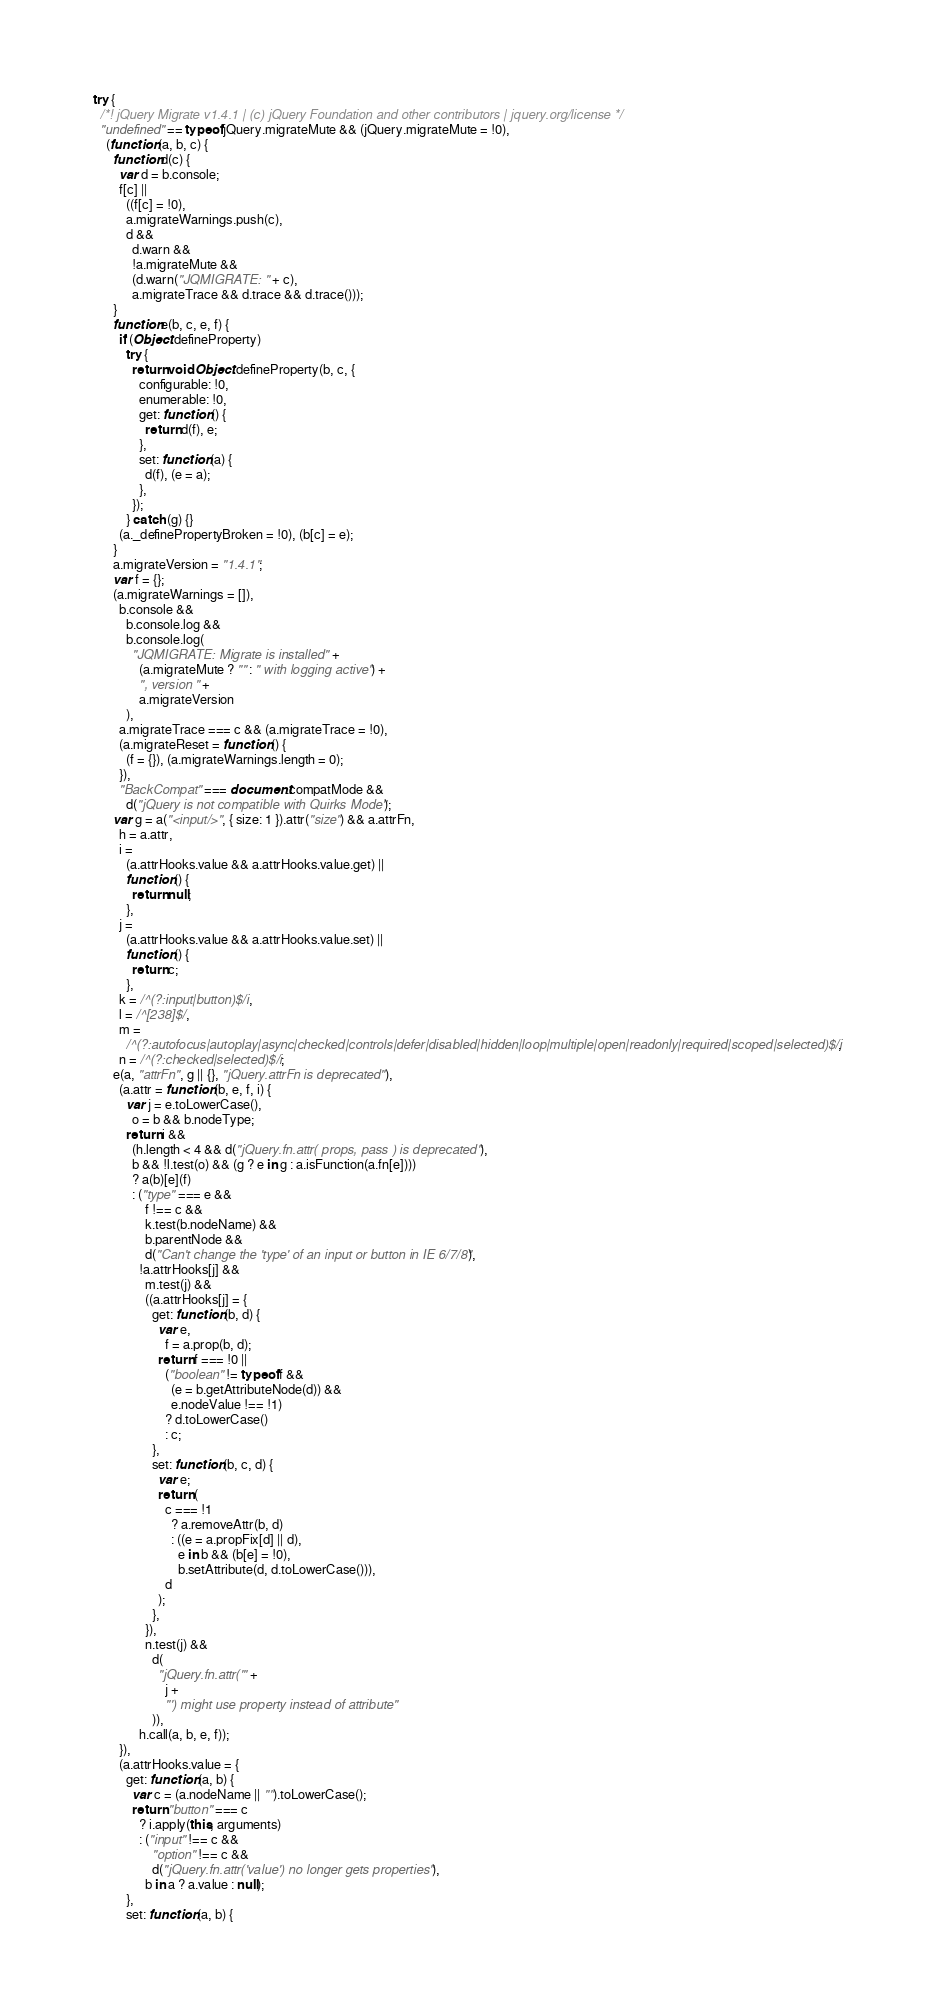<code> <loc_0><loc_0><loc_500><loc_500><_JavaScript_>try {
  /*! jQuery Migrate v1.4.1 | (c) jQuery Foundation and other contributors | jquery.org/license */
  "undefined" == typeof jQuery.migrateMute && (jQuery.migrateMute = !0),
    (function (a, b, c) {
      function d(c) {
        var d = b.console;
        f[c] ||
          ((f[c] = !0),
          a.migrateWarnings.push(c),
          d &&
            d.warn &&
            !a.migrateMute &&
            (d.warn("JQMIGRATE: " + c),
            a.migrateTrace && d.trace && d.trace()));
      }
      function e(b, c, e, f) {
        if (Object.defineProperty)
          try {
            return void Object.defineProperty(b, c, {
              configurable: !0,
              enumerable: !0,
              get: function () {
                return d(f), e;
              },
              set: function (a) {
                d(f), (e = a);
              },
            });
          } catch (g) {}
        (a._definePropertyBroken = !0), (b[c] = e);
      }
      a.migrateVersion = "1.4.1";
      var f = {};
      (a.migrateWarnings = []),
        b.console &&
          b.console.log &&
          b.console.log(
            "JQMIGRATE: Migrate is installed" +
              (a.migrateMute ? "" : " with logging active") +
              ", version " +
              a.migrateVersion
          ),
        a.migrateTrace === c && (a.migrateTrace = !0),
        (a.migrateReset = function () {
          (f = {}), (a.migrateWarnings.length = 0);
        }),
        "BackCompat" === document.compatMode &&
          d("jQuery is not compatible with Quirks Mode");
      var g = a("<input/>", { size: 1 }).attr("size") && a.attrFn,
        h = a.attr,
        i =
          (a.attrHooks.value && a.attrHooks.value.get) ||
          function () {
            return null;
          },
        j =
          (a.attrHooks.value && a.attrHooks.value.set) ||
          function () {
            return c;
          },
        k = /^(?:input|button)$/i,
        l = /^[238]$/,
        m =
          /^(?:autofocus|autoplay|async|checked|controls|defer|disabled|hidden|loop|multiple|open|readonly|required|scoped|selected)$/i,
        n = /^(?:checked|selected)$/i;
      e(a, "attrFn", g || {}, "jQuery.attrFn is deprecated"),
        (a.attr = function (b, e, f, i) {
          var j = e.toLowerCase(),
            o = b && b.nodeType;
          return i &&
            (h.length < 4 && d("jQuery.fn.attr( props, pass ) is deprecated"),
            b && !l.test(o) && (g ? e in g : a.isFunction(a.fn[e])))
            ? a(b)[e](f)
            : ("type" === e &&
                f !== c &&
                k.test(b.nodeName) &&
                b.parentNode &&
                d("Can't change the 'type' of an input or button in IE 6/7/8"),
              !a.attrHooks[j] &&
                m.test(j) &&
                ((a.attrHooks[j] = {
                  get: function (b, d) {
                    var e,
                      f = a.prop(b, d);
                    return f === !0 ||
                      ("boolean" != typeof f &&
                        (e = b.getAttributeNode(d)) &&
                        e.nodeValue !== !1)
                      ? d.toLowerCase()
                      : c;
                  },
                  set: function (b, c, d) {
                    var e;
                    return (
                      c === !1
                        ? a.removeAttr(b, d)
                        : ((e = a.propFix[d] || d),
                          e in b && (b[e] = !0),
                          b.setAttribute(d, d.toLowerCase())),
                      d
                    );
                  },
                }),
                n.test(j) &&
                  d(
                    "jQuery.fn.attr('" +
                      j +
                      "') might use property instead of attribute"
                  )),
              h.call(a, b, e, f));
        }),
        (a.attrHooks.value = {
          get: function (a, b) {
            var c = (a.nodeName || "").toLowerCase();
            return "button" === c
              ? i.apply(this, arguments)
              : ("input" !== c &&
                  "option" !== c &&
                  d("jQuery.fn.attr('value') no longer gets properties"),
                b in a ? a.value : null);
          },
          set: function (a, b) {</code> 